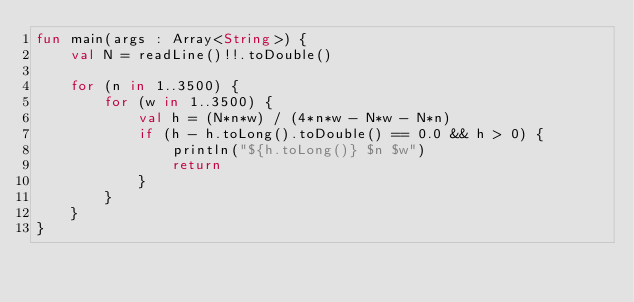<code> <loc_0><loc_0><loc_500><loc_500><_Kotlin_>fun main(args : Array<String>) {
    val N = readLine()!!.toDouble()

    for (n in 1..3500) {
        for (w in 1..3500) {
            val h = (N*n*w) / (4*n*w - N*w - N*n)
            if (h - h.toLong().toDouble() == 0.0 && h > 0) {
                println("${h.toLong()} $n $w")
                return
            }
        }
    }
}</code> 